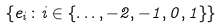Convert formula to latex. <formula><loc_0><loc_0><loc_500><loc_500>\{ e _ { i } \colon i \in \{ \dots , - 2 , - 1 , 0 , 1 \} \}</formula> 